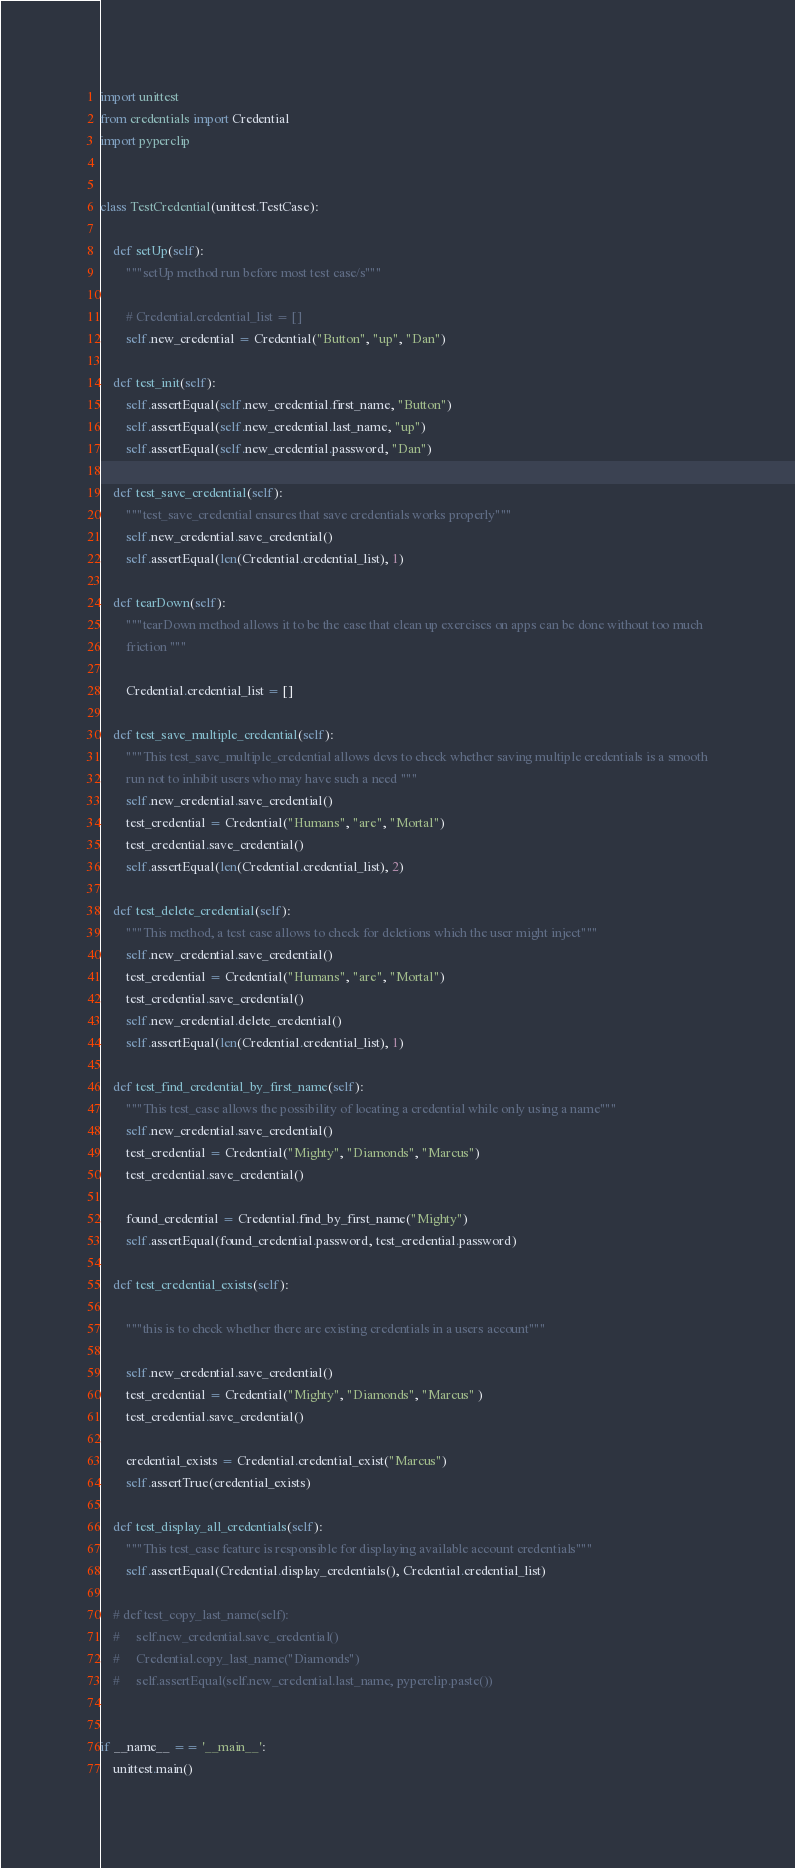Convert code to text. <code><loc_0><loc_0><loc_500><loc_500><_Python_>import unittest
from credentials import Credential
import pyperclip


class TestCredential(unittest.TestCase):

    def setUp(self):
        """setUp method run before most test case/s"""

        # Credential.credential_list = []
        self.new_credential = Credential("Button", "up", "Dan")

    def test_init(self):
        self.assertEqual(self.new_credential.first_name, "Button")
        self.assertEqual(self.new_credential.last_name, "up")
        self.assertEqual(self.new_credential.password, "Dan")

    def test_save_credential(self):
        """test_save_credential ensures that save credentials works properly"""
        self.new_credential.save_credential()
        self.assertEqual(len(Credential.credential_list), 1)

    def tearDown(self):
        """tearDown method allows it to be the case that clean up exercises on apps can be done without too much
        friction """

        Credential.credential_list = []

    def test_save_multiple_credential(self):
        """This test_save_multiple_credential allows devs to check whether saving multiple credentials is a smooth
        run not to inhibit users who may have such a need """
        self.new_credential.save_credential()
        test_credential = Credential("Humans", "are", "Mortal")
        test_credential.save_credential()
        self.assertEqual(len(Credential.credential_list), 2)

    def test_delete_credential(self):
        """This method, a test case allows to check for deletions which the user might inject"""
        self.new_credential.save_credential()
        test_credential = Credential("Humans", "are", "Mortal")
        test_credential.save_credential()
        self.new_credential.delete_credential()
        self.assertEqual(len(Credential.credential_list), 1)

    def test_find_credential_by_first_name(self):
        """This test_case allows the possibility of locating a credential while only using a name"""
        self.new_credential.save_credential()
        test_credential = Credential("Mighty", "Diamonds", "Marcus")
        test_credential.save_credential()

        found_credential = Credential.find_by_first_name("Mighty")
        self.assertEqual(found_credential.password, test_credential.password)

    def test_credential_exists(self):

        """this is to check whether there are existing credentials in a users account"""

        self.new_credential.save_credential()
        test_credential = Credential("Mighty", "Diamonds", "Marcus" )
        test_credential.save_credential()

        credential_exists = Credential.credential_exist("Marcus")
        self.assertTrue(credential_exists)

    def test_display_all_credentials(self):
        """This test_case feature is responsible for displaying available account credentials"""
        self.assertEqual(Credential.display_credentials(), Credential.credential_list)

    # def test_copy_last_name(self):
    #     self.new_credential.save_credential()
    #     Credential.copy_last_name("Diamonds")
    #     self.assertEqual(self.new_credential.last_name, pyperclip.paste())


if __name__ == '__main__':
    unittest.main()

</code> 